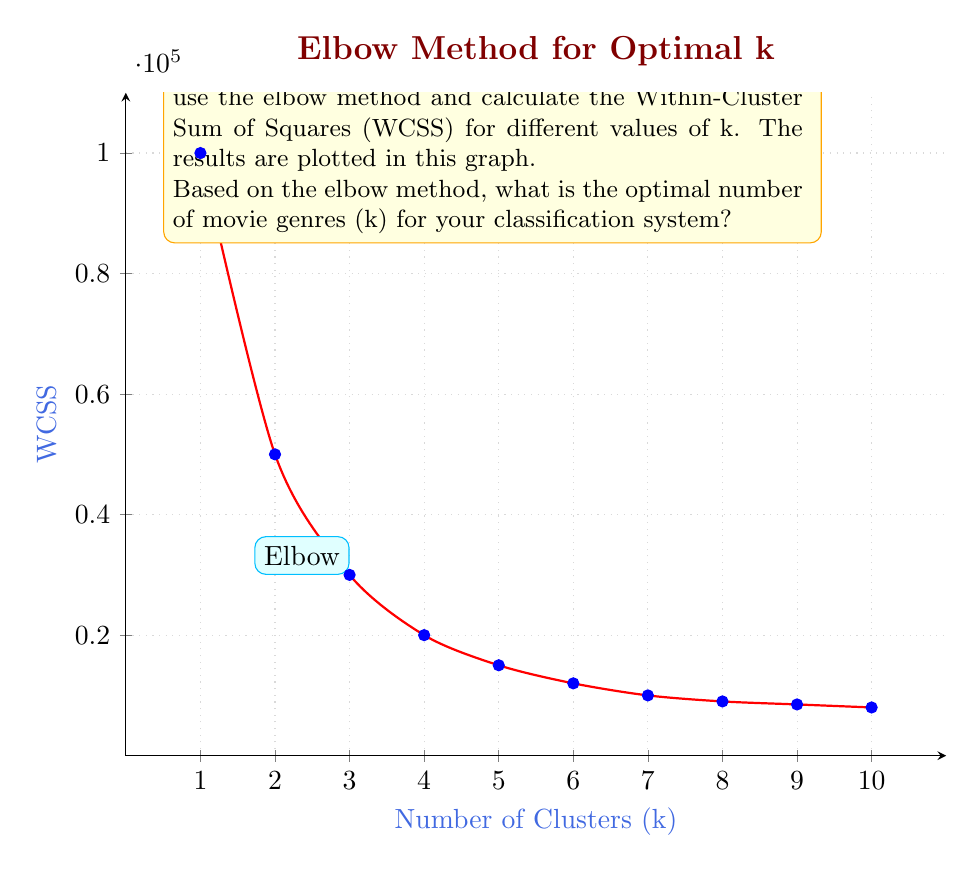Teach me how to tackle this problem. To determine the optimal number of clusters (k) using the elbow method, we need to follow these steps:

1. Understand the elbow method:
   The elbow method looks for a point where the rate of decrease in WCSS starts to level off, forming an "elbow" in the graph.

2. Analyze the graph:
   - The x-axis represents the number of clusters (k)
   - The y-axis represents the Within-Cluster Sum of Squares (WCSS)
   - As k increases, WCSS generally decreases

3. Identify the elbow point:
   - Look for a point where the rate of decrease in WCSS slows down significantly
   - This point represents the optimal balance between cluster compactness and the number of clusters

4. Interpret the graph:
   - From k=1 to k=3, there's a steep decrease in WCSS
   - At k=3, we see an "elbow" forming
   - After k=3, the decrease in WCSS becomes more gradual

5. Make a decision:
   The optimal number of clusters (k) is at the elbow point, which in this case is k=3

Therefore, based on the elbow method, the optimal number of movie genres for your classification system is 3.
Answer: 3 